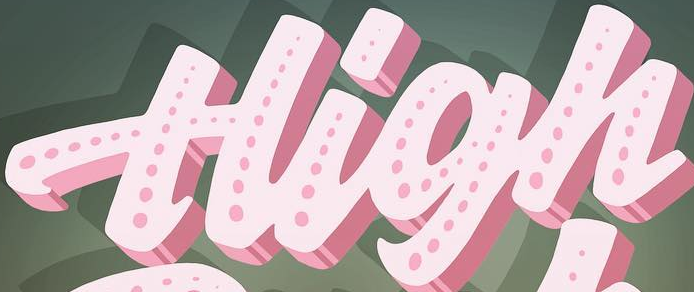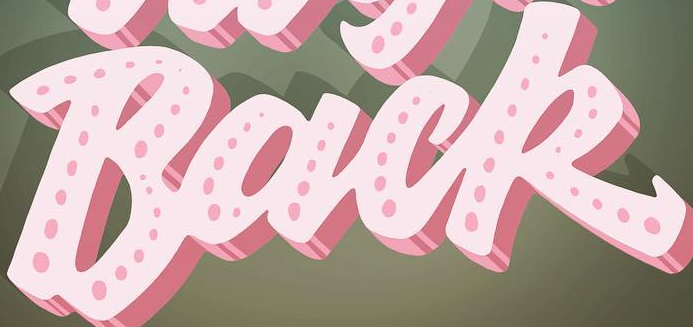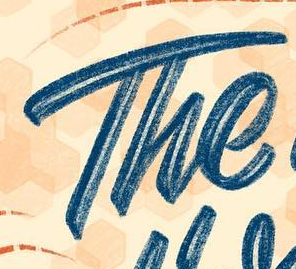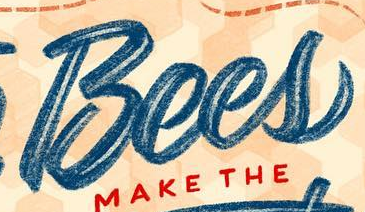What words can you see in these images in sequence, separated by a semicolon? High; Back; The; Bees 